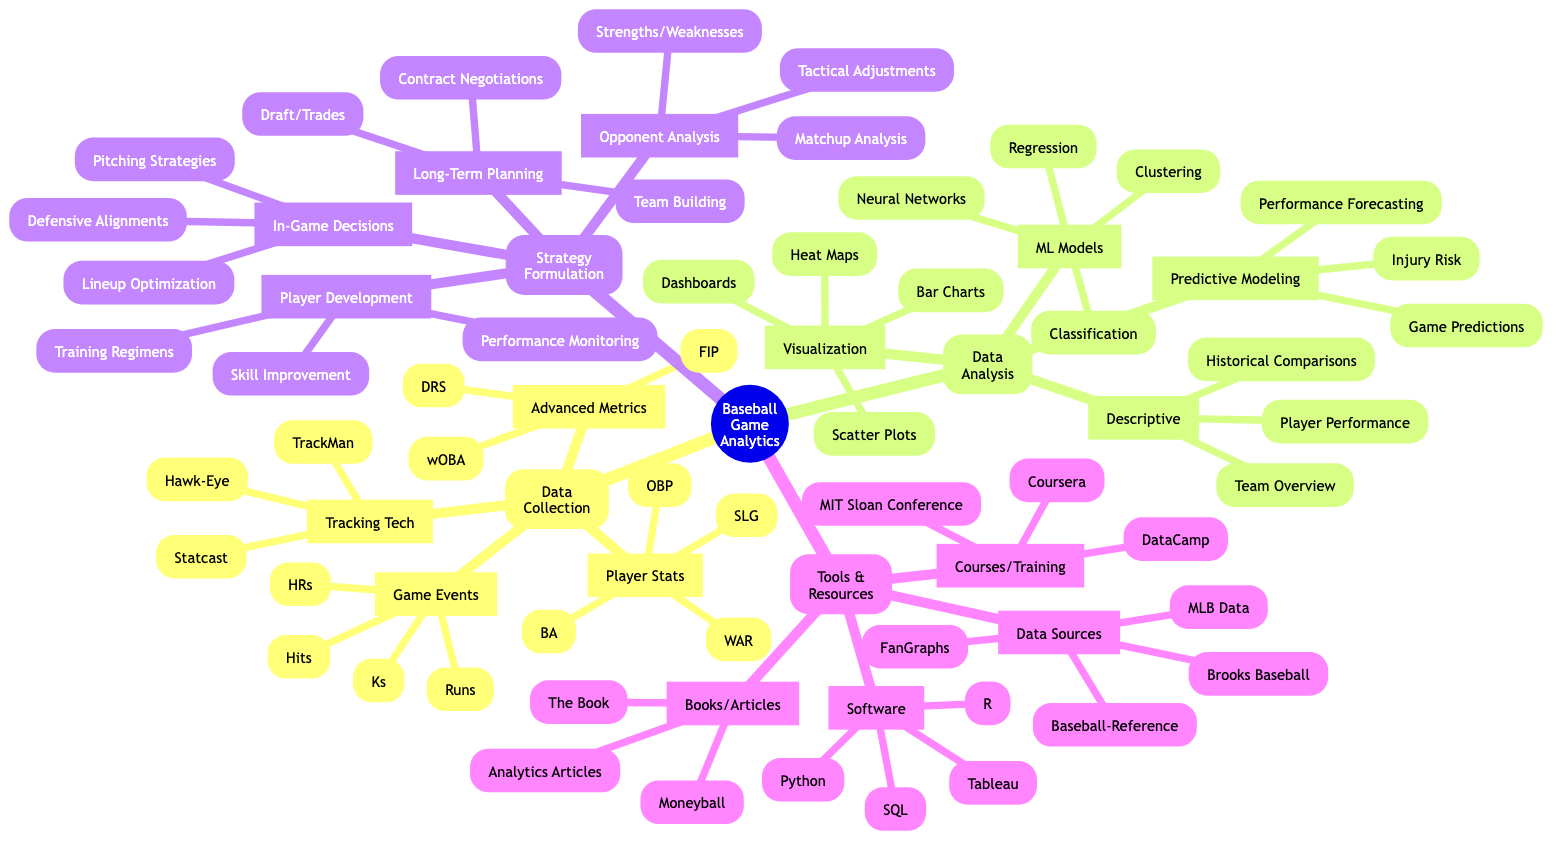What's the main topic of the mind map? The main topic is indicated as the root node of the mind map, which outlines the overall focus on baseball game analytics.
Answer: Baseball Game Analytics How many subtopics are included in the mind map? The mind map includes four subtopics branching from the main topic: Data Collection, Data Analysis, Strategy Formulation, and Tools and Resources. Count them for verification.
Answer: 4 What percentage of subtopics focuses on Data Collection? There is one subtopic dedicated to Data Collection out of a total of four, which represents 25% of the subtopics in the diagram. This is calculated as (1/4)*100.
Answer: 25% Name two types of advanced metrics listed under Data Collection? The diagram lists specific elements under Data Collection, including Advanced Metrics. Two examples are Fielding Independent Pitching and Weighted On-Base Average, which are specifically highlighted there.
Answer: FIP, wOBA Which strategy formulation includes in-game decisions? The mind map specifies that In-Game Decisions is a part of the Strategy Formulation subtopic, highlighting its focus on gameplay strategy.
Answer: In-Game Decisions What tools are suggested under the Software category? The Software section lists specific tools for analytics. The diagram mentions R, Python, SQL, and Tableau as the software options available for analysis.
Answer: R, Python, SQL, Tableau Which type of analysis helps in player performance forecasting? The diagram categorizes Predictive Modeling under Data Analysis, indicating that it includes aspects like Player Performance Forecasting, which is tied directly to the analysis of a player's future performance.
Answer: Predictive Modeling How many visualization tools are mentioned in the mind map? Under the Visualization Tools category in Data Analysis, there are four distinct visualization methods referenced: Heat Maps, Bar Charts, Scatter Plots, and Interactive Dashboards. Thus, the total count is four.
Answer: 4 What is one resource type mentioned for enhancing baseball analytics knowledge? The diagram mentions multiple resource types, but one key type is Books and Articles, which includes titles such as Moneyball and Advanced Baseball Analytics Articles.
Answer: Books and Articles 